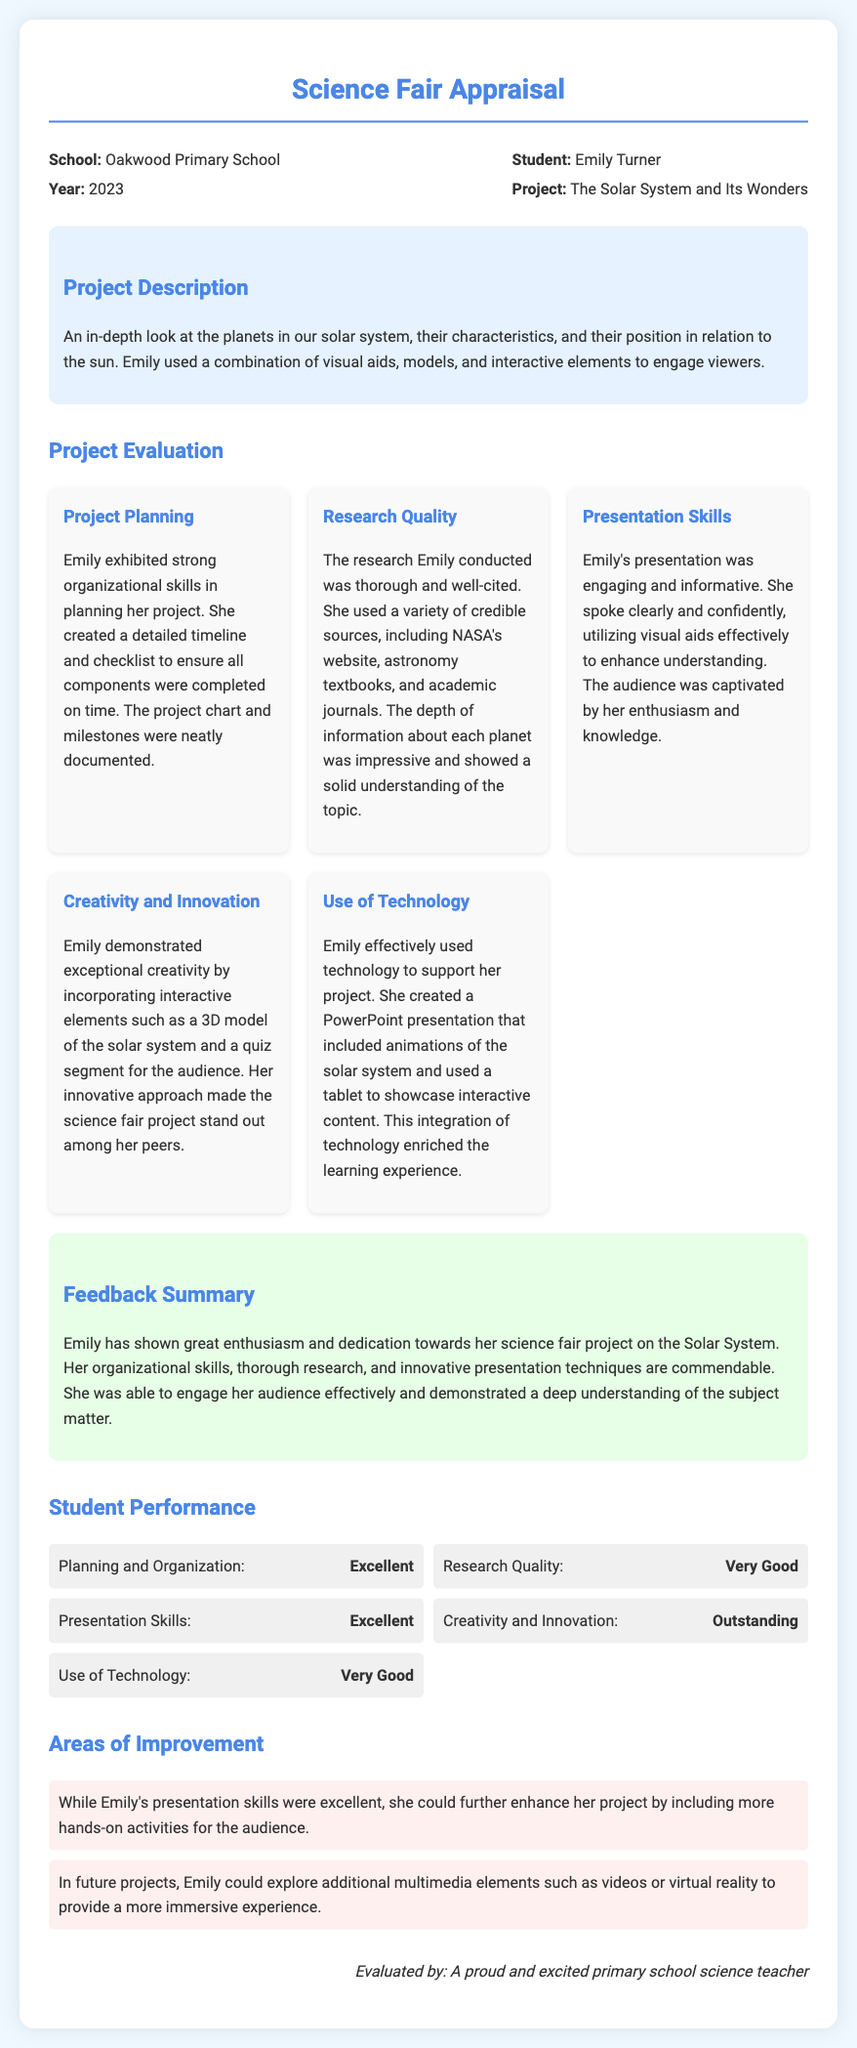What is the name of the student? The student's name is mentioned in the header section of the document.
Answer: Emily Turner What project did Emily present? The project title can be found in the header section of the document.
Answer: The Solar System and Its Wonders What is the student's school name? The school's name is listed in the header near the student's information.
Answer: Oakwood Primary School What year is the appraisal for? The year is specified in the header section alongside the school name.
Answer: 2023 Which aspect of Emily's performance received the rating "Outstanding"? The performance ratings are outlined in the Student Performance section, detailing specific ratings for areas.
Answer: Creativity and Innovation What feedback was given regarding Emily's research quality? The feedback summary addresses the quality of research conducted by Emily in her project.
Answer: Very Good How many areas of improvement are noted for Emily? The document lists the areas of improvement at the end of the feedback section.
Answer: 2 What technology did Emily use for her project? The details about technology usage are mentioned in the evaluation section related to the project.
Answer: PowerPoint presentation Who evaluated the project? The evaluator's name is mentioned at the end of the document.
Answer: A proud and excited primary school science teacher 